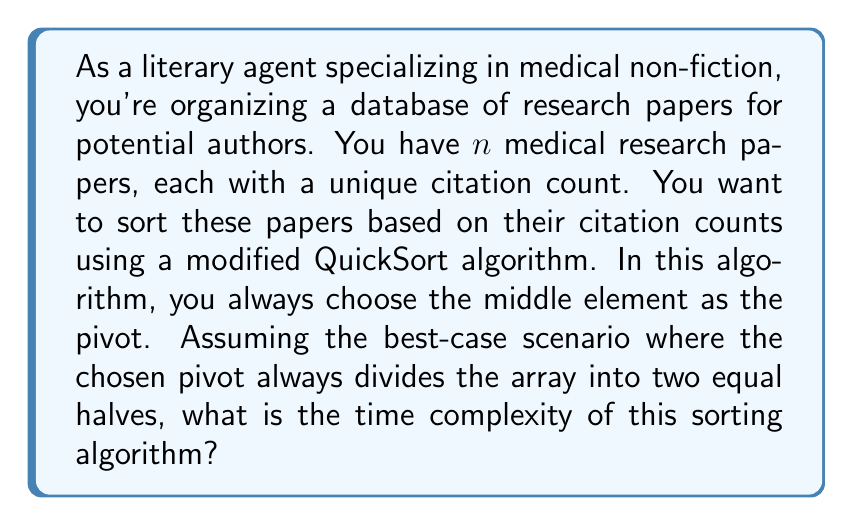Can you solve this math problem? Let's analyze this step-by-step:

1) In the best-case scenario of QuickSort, the pivot always divides the array into two equal halves. This means that in each recursion, we're dividing the problem size by 2.

2) The recurrence relation for this scenario can be written as:

   $$T(n) = 2T(n/2) + O(n)$$

   Where $T(n)$ is the time complexity for input size $n$, $2T(n/2)$ represents the two recursive calls on halves of the array, and $O(n)$ is the time taken to partition the array around the pivot.

3) This recurrence relation fits the Master Theorem case where $a=2$, $b=2$, and $f(n) = O(n)$.

4) In the Master Theorem, we compare $n^{\log_b a}$ with $f(n)$:

   $$n^{\log_2 2} = n^1 = n$$

   Which is asymptotically the same as $f(n) = O(n)$

5) This corresponds to Case 2 of the Master Theorem, where $n^{\log_b a} = \Theta(f(n))$.

6) For this case, the solution to the recurrence is:

   $$T(n) = \Theta(n \log n)$$

Therefore, even in the best-case scenario, the time complexity of this QuickSort variant is $\Theta(n \log n)$.
Answer: $\Theta(n \log n)$ 